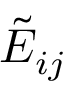Convert formula to latex. <formula><loc_0><loc_0><loc_500><loc_500>{ \tilde { E } } _ { i j }</formula> 